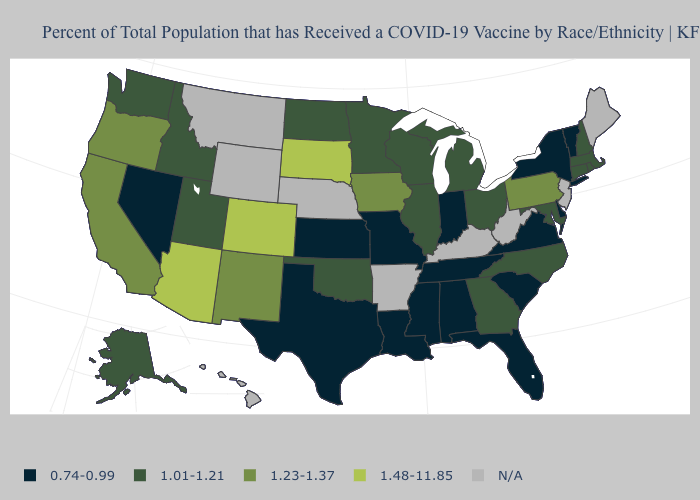Name the states that have a value in the range 0.74-0.99?
Write a very short answer. Alabama, Delaware, Florida, Indiana, Kansas, Louisiana, Mississippi, Missouri, Nevada, New York, South Carolina, Tennessee, Texas, Vermont, Virginia. Which states have the lowest value in the MidWest?
Write a very short answer. Indiana, Kansas, Missouri. Among the states that border Georgia , which have the highest value?
Write a very short answer. North Carolina. Which states hav the highest value in the South?
Give a very brief answer. Georgia, Maryland, North Carolina, Oklahoma. Name the states that have a value in the range 1.48-11.85?
Write a very short answer. Arizona, Colorado, South Dakota. What is the highest value in the USA?
Concise answer only. 1.48-11.85. Among the states that border Arkansas , does Louisiana have the highest value?
Be succinct. No. Which states hav the highest value in the South?
Write a very short answer. Georgia, Maryland, North Carolina, Oklahoma. How many symbols are there in the legend?
Concise answer only. 5. Among the states that border Arizona , which have the highest value?
Give a very brief answer. Colorado. What is the value of Delaware?
Quick response, please. 0.74-0.99. Name the states that have a value in the range 1.23-1.37?
Quick response, please. California, Iowa, New Mexico, Oregon, Pennsylvania. Which states have the highest value in the USA?
Keep it brief. Arizona, Colorado, South Dakota. 